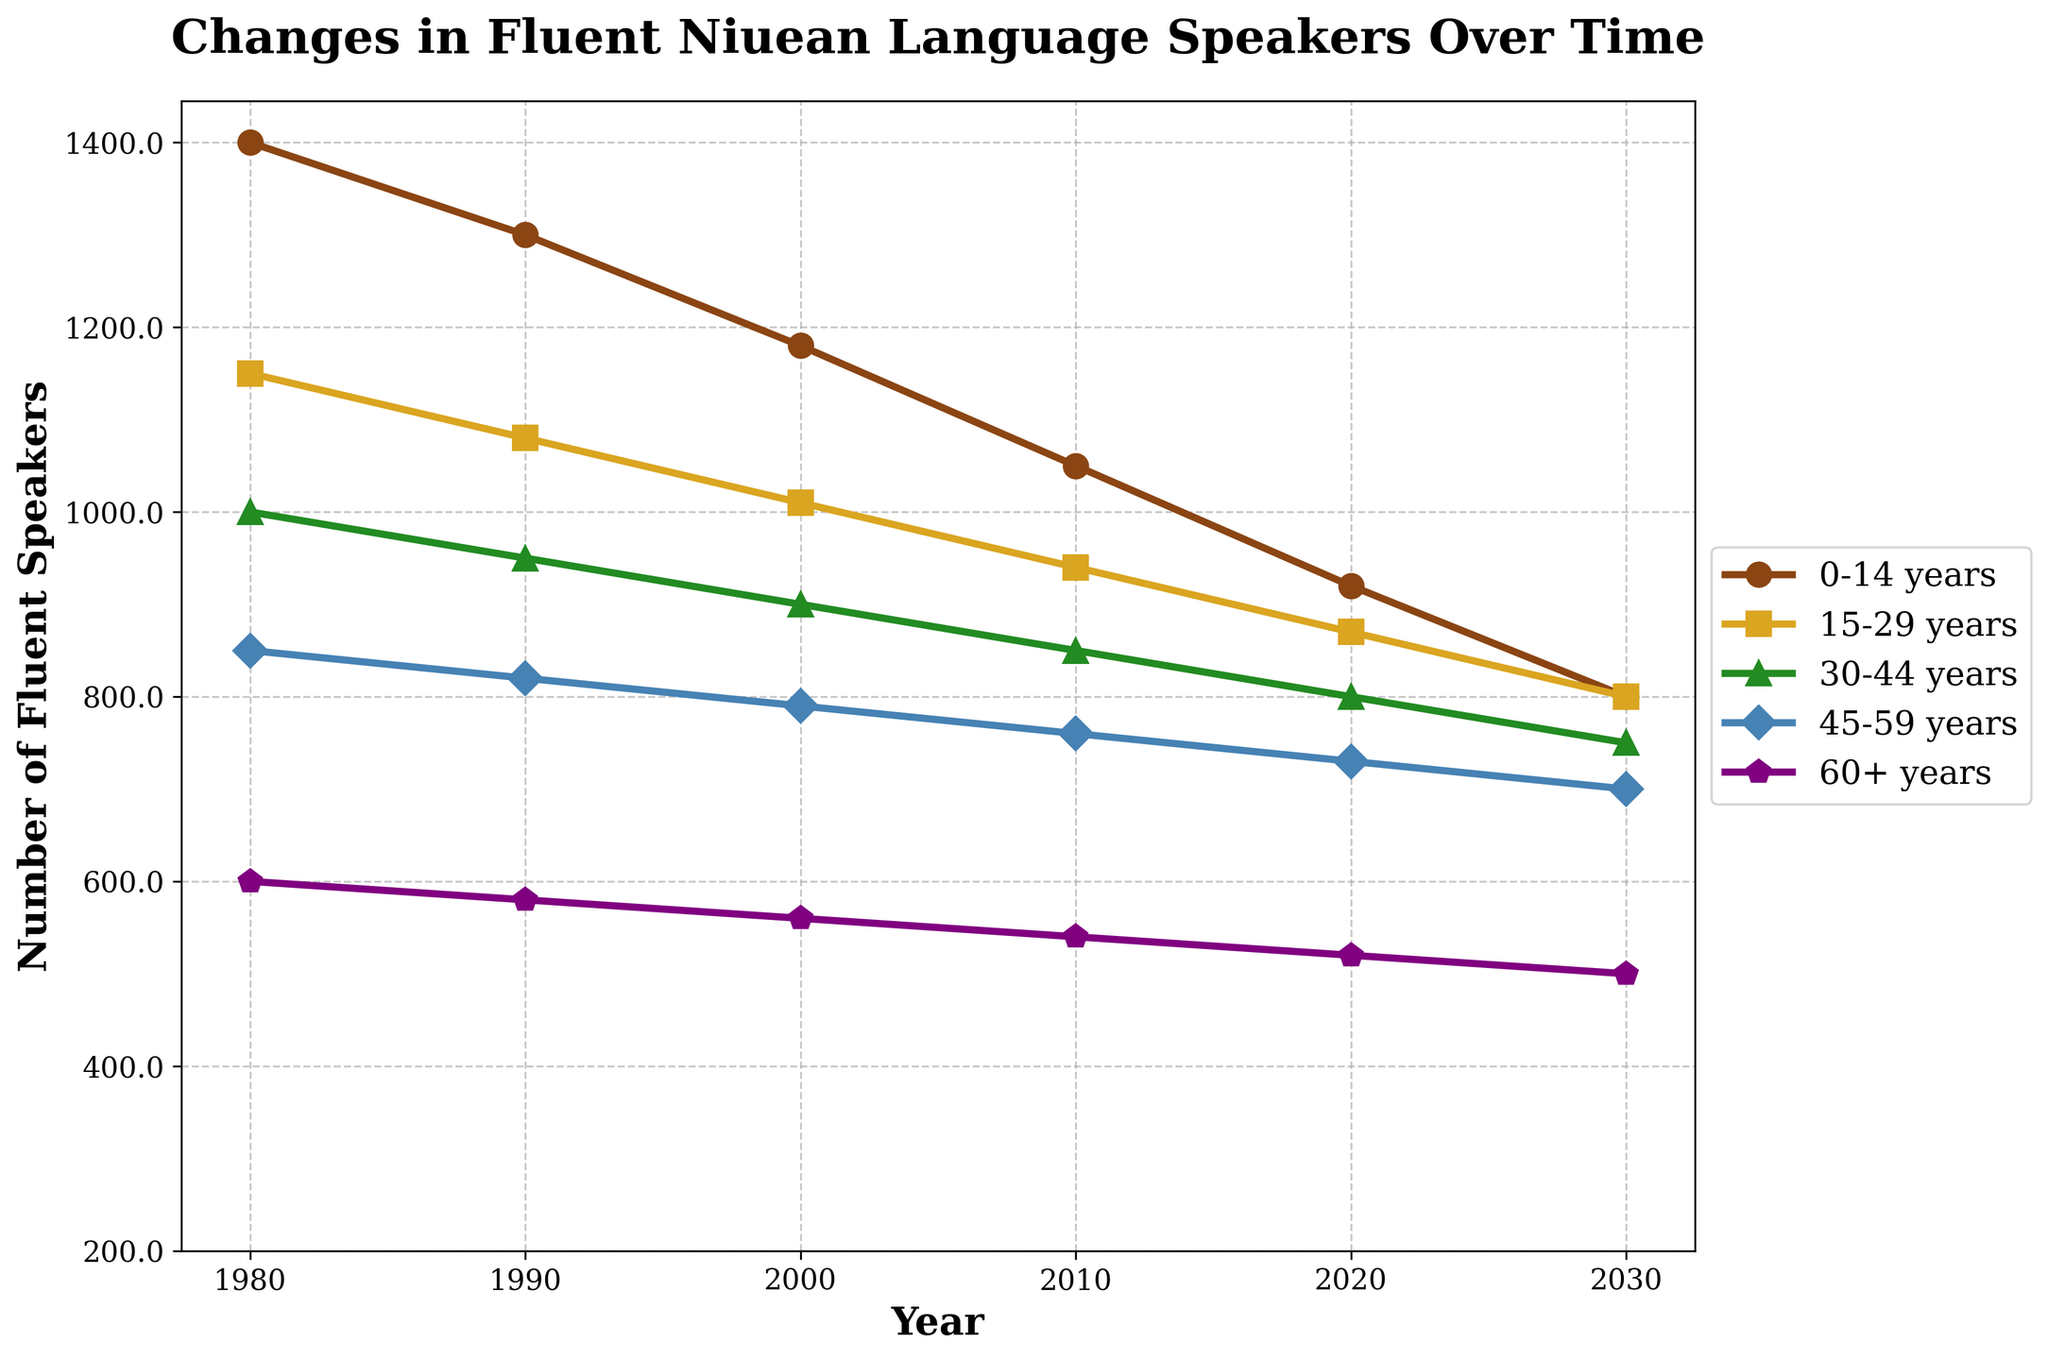What is the overall trend in the number of fluent Niuean speakers aged 0-14 years from 1980 to 2030? To find the trend, observe the line representing the 0-14 years age group. It begins at 1200 in 1980 and decreases steadily over time, reaching 600 in 2030. This indicates a consistent downward trend.
Answer: Decreasing In which year did the number of fluent speakers aged 60+ years drop below 400? Look at the line for the 60+ years age group and check the values for each year. The number is 400 in 1980 and decreases to 380 in 1990, which is the first drop below 400.
Answer: 1990 Which age group experienced the smallest decrease in the number of fluent speakers between 1980 and 2030? Calculate the difference for each age group: 
0-14 years: 1200 - 600 = 600
15-29 years: 950 - 600 = 350
30-44 years: 800 - 550 = 250
45-59 years: 650 - 500 = 150
60+ years: 400 - 300 = 100
The 60+ years age group experienced the smallest decrease, with a reduction of 100 speakers.
Answer: 60+ years By how much did the number of fluent speakers aged 0-14 years change from 1990 to 2020? Subtract the number in 2020 from the number in 1990: 1100 - 720 = 380. The change is a decrease of 380 speakers.
Answer: 380 Which age group had the steepest decline between 1980 and 2030? Calculate the slope (difference in value divided by difference in years) for each group:
0-14 years: (600 - 1200) / (2030 - 1980) = -600 / 50 = -12
15-29 years: (600 - 950) / 50 = -7
30-44 years: (550 - 800) / 50 = -5
45-59 years: (500 - 650) / 50 = -3
60+ years: (300 - 400) / 50 = -2
The 0-14 years group had the steepest decline with a slope of -12.
Answer: 0-14 years In which year are all age groups expected to have fewer than 600 fluent speakers? Observe the intersection points where each group's line falls below 600. All age groups fall below 600 by the year 2030.
Answer: 2030 How many fluent speakers in total were there across all age groups in 1980? Sum the values of all age groups for the year 1980:
1200 (0-14) + 950 (15-29) + 800 (30-44) + 650 (45-59) + 400 (60+) = 4000.
Answer: 4000 Between which consecutive decades did the age group 0-14 years experience the largest absolute drop in the number of fluent speakers? Calculate the drop between consecutive intervals:
1980-1990: 1200 - 1100 = 100
1990-2000: 1100 - 980 = 120
2000-2010: 980 - 850 = 130
2010-2020: 850 - 720 = 130
2020-2030: 720 - 600 = 120
The drops between 2000-2010 and 2010-2020 are tied at 130.
Answer: 2000-2010, 2010-2020 